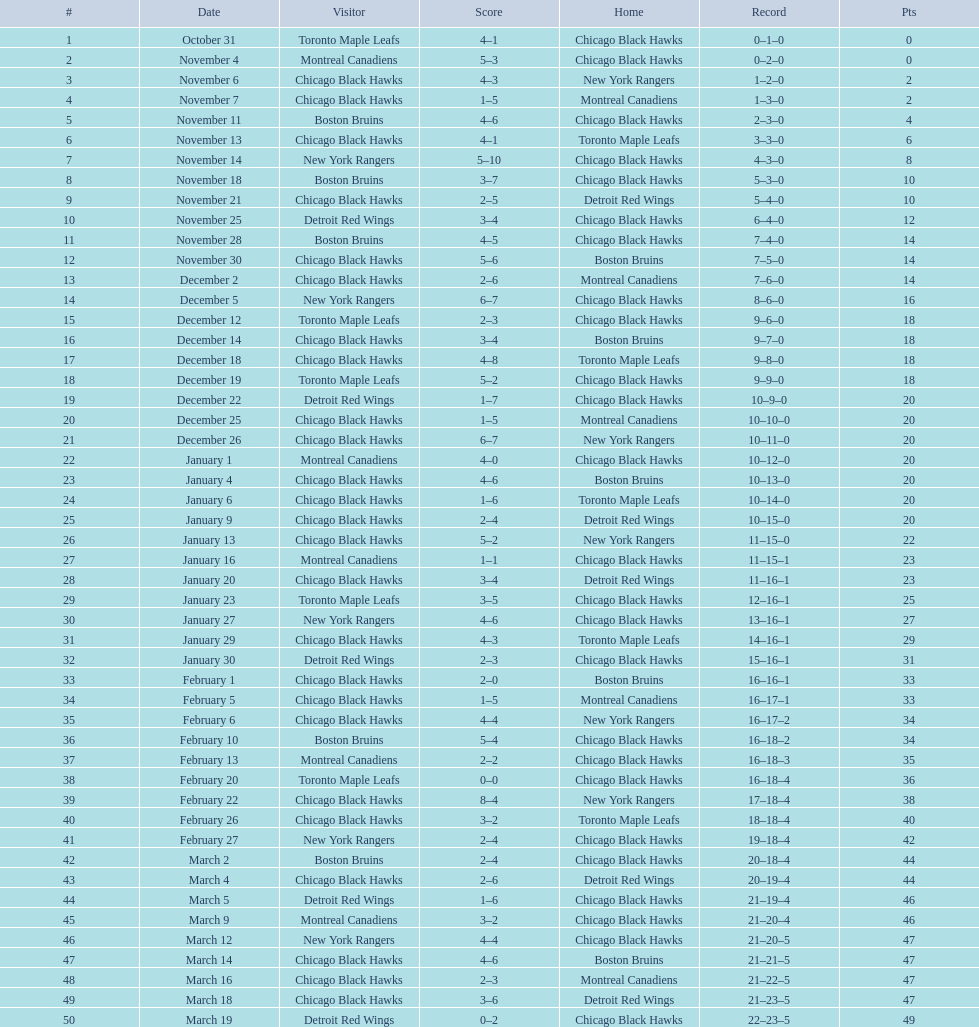Which team was the first one the black hawks suffered a loss to? Toronto Maple Leafs. 